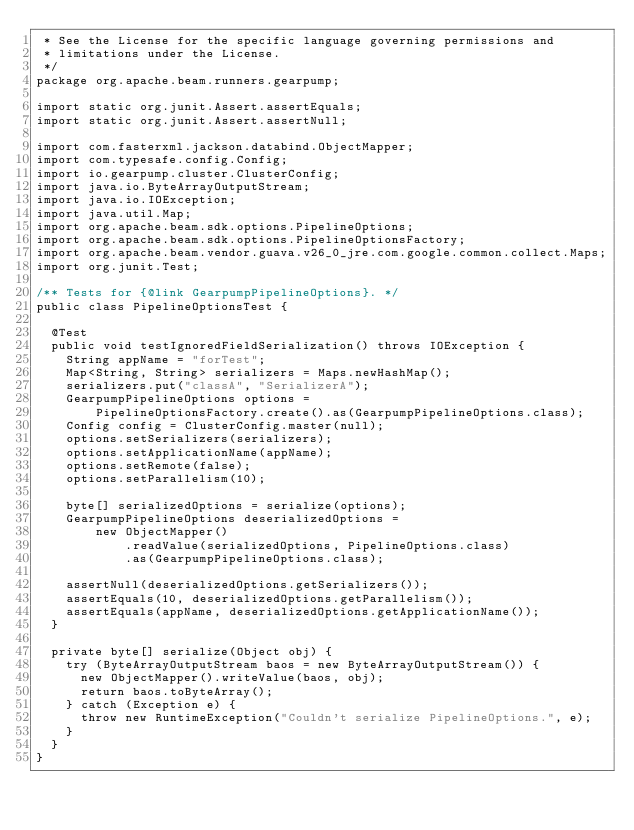<code> <loc_0><loc_0><loc_500><loc_500><_Java_> * See the License for the specific language governing permissions and
 * limitations under the License.
 */
package org.apache.beam.runners.gearpump;

import static org.junit.Assert.assertEquals;
import static org.junit.Assert.assertNull;

import com.fasterxml.jackson.databind.ObjectMapper;
import com.typesafe.config.Config;
import io.gearpump.cluster.ClusterConfig;
import java.io.ByteArrayOutputStream;
import java.io.IOException;
import java.util.Map;
import org.apache.beam.sdk.options.PipelineOptions;
import org.apache.beam.sdk.options.PipelineOptionsFactory;
import org.apache.beam.vendor.guava.v26_0_jre.com.google.common.collect.Maps;
import org.junit.Test;

/** Tests for {@link GearpumpPipelineOptions}. */
public class PipelineOptionsTest {

  @Test
  public void testIgnoredFieldSerialization() throws IOException {
    String appName = "forTest";
    Map<String, String> serializers = Maps.newHashMap();
    serializers.put("classA", "SerializerA");
    GearpumpPipelineOptions options =
        PipelineOptionsFactory.create().as(GearpumpPipelineOptions.class);
    Config config = ClusterConfig.master(null);
    options.setSerializers(serializers);
    options.setApplicationName(appName);
    options.setRemote(false);
    options.setParallelism(10);

    byte[] serializedOptions = serialize(options);
    GearpumpPipelineOptions deserializedOptions =
        new ObjectMapper()
            .readValue(serializedOptions, PipelineOptions.class)
            .as(GearpumpPipelineOptions.class);

    assertNull(deserializedOptions.getSerializers());
    assertEquals(10, deserializedOptions.getParallelism());
    assertEquals(appName, deserializedOptions.getApplicationName());
  }

  private byte[] serialize(Object obj) {
    try (ByteArrayOutputStream baos = new ByteArrayOutputStream()) {
      new ObjectMapper().writeValue(baos, obj);
      return baos.toByteArray();
    } catch (Exception e) {
      throw new RuntimeException("Couldn't serialize PipelineOptions.", e);
    }
  }
}
</code> 